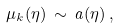<formula> <loc_0><loc_0><loc_500><loc_500>\mu _ { k } ( \eta ) \, \sim \, a ( \eta ) \, ,</formula> 